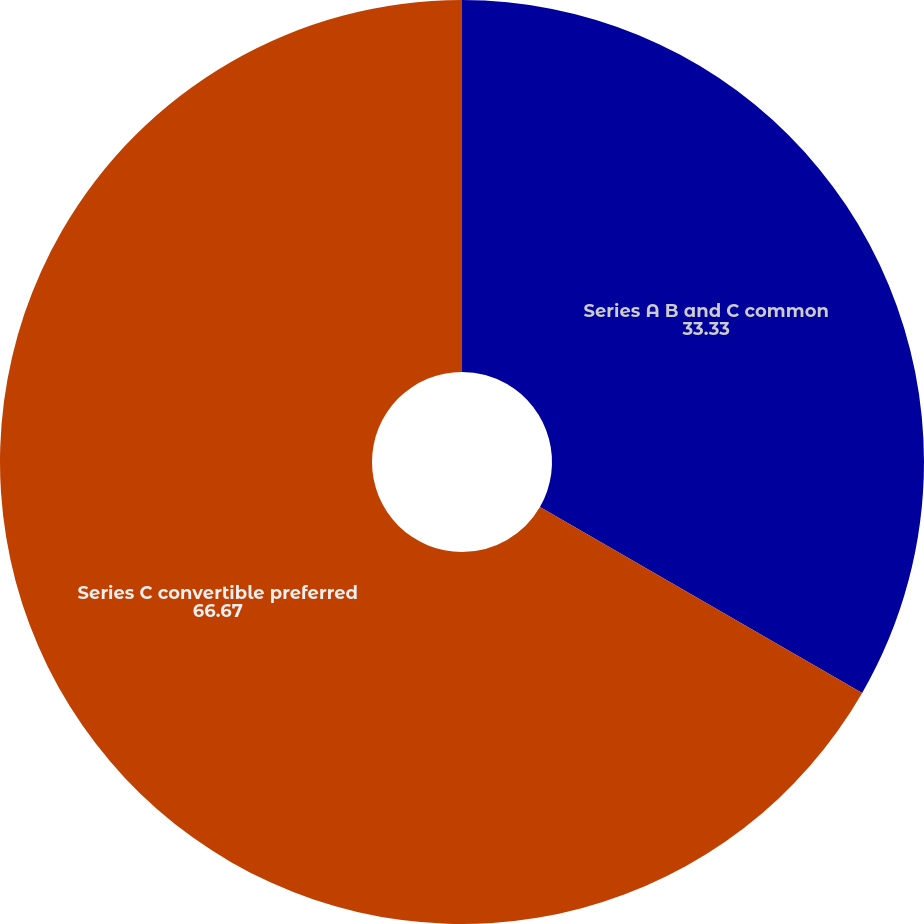<chart> <loc_0><loc_0><loc_500><loc_500><pie_chart><fcel>Series A B and C common<fcel>Series C convertible preferred<nl><fcel>33.33%<fcel>66.67%<nl></chart> 